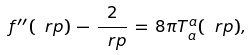<formula> <loc_0><loc_0><loc_500><loc_500>f ^ { \prime \prime } ( \ r p ) \, - \, \frac { 2 } { \ r p } \, = \, 8 \pi T _ { a } ^ { a } ( \ r p ) ,</formula> 